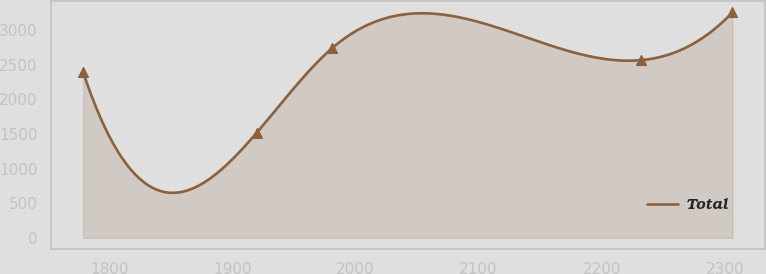Convert chart to OTSL. <chart><loc_0><loc_0><loc_500><loc_500><line_chart><ecel><fcel>Total<nl><fcel>1778.75<fcel>2392.64<nl><fcel>1919.72<fcel>1517.57<nl><fcel>1981.02<fcel>2740.58<nl><fcel>2231.56<fcel>2566.61<nl><fcel>2306.22<fcel>3257.28<nl></chart> 